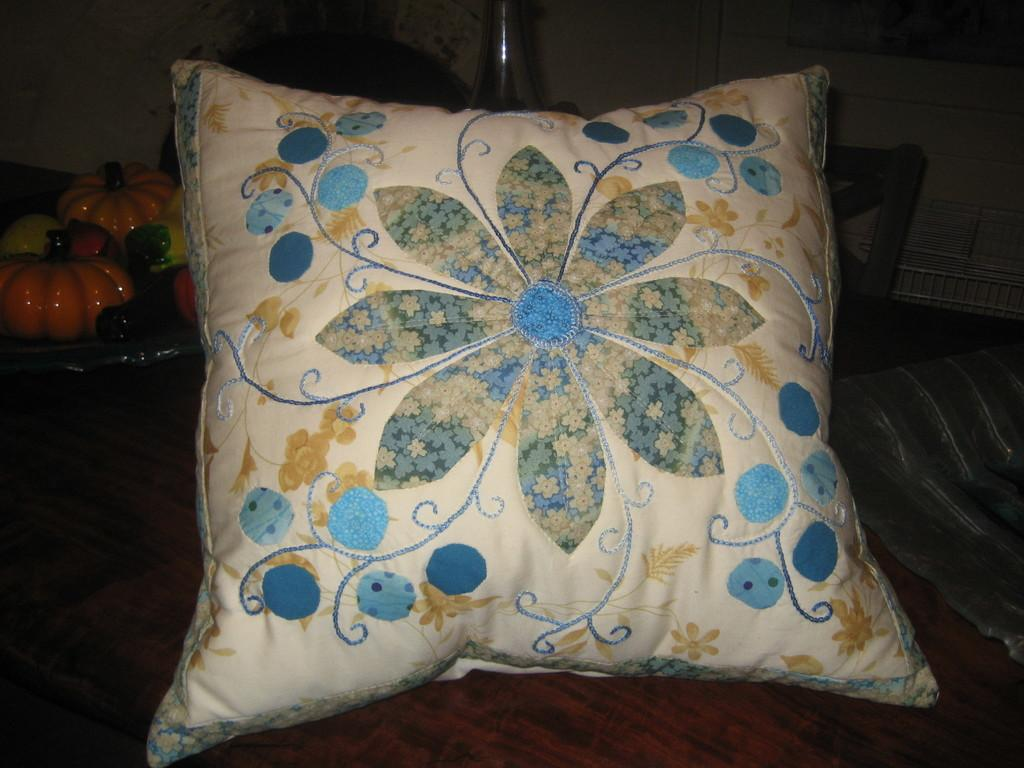What is placed on the bed in the image? There is a pillow on the bed in the image. What can be seen on a separate piece of furniture in the image? There are fruits on a table in the image. What type of calculator is being used to measure the root of the fruit in the image? There is no calculator or measurement of roots present in the image; it simply shows a pillow on the bed and fruits on a table. 